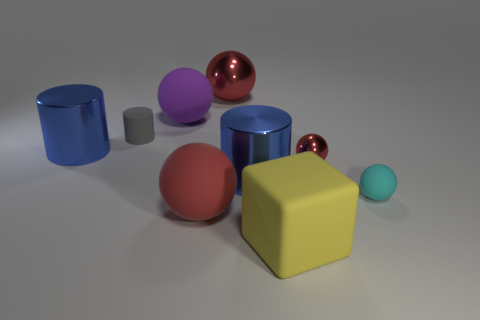Subtract all red spheres. How many were subtracted if there are1red spheres left? 2 Subtract all cyan cylinders. How many red spheres are left? 3 Subtract 2 spheres. How many spheres are left? 3 Subtract all purple spheres. How many spheres are left? 4 Subtract all large red metal spheres. How many spheres are left? 4 Subtract all blue balls. Subtract all cyan cylinders. How many balls are left? 5 Subtract all cylinders. How many objects are left? 6 Add 6 shiny cylinders. How many shiny cylinders are left? 8 Add 6 small cyan rubber things. How many small cyan rubber things exist? 7 Subtract 1 cyan balls. How many objects are left? 8 